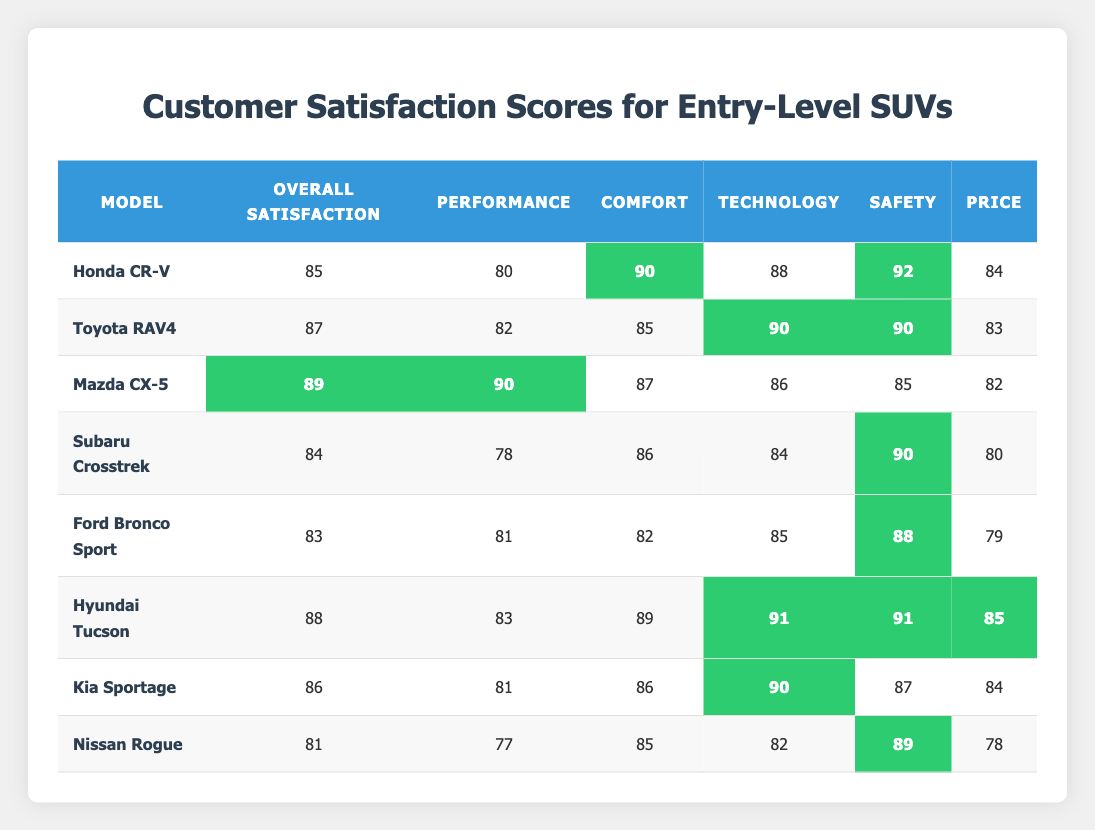What is the overall satisfaction score for the Mazda CX-5? The overall satisfaction score for the Mazda CX-5 is listed directly in the table and is indicated as 89.
Answer: 89 Which SUV has the highest comfort rating? According to the table, the Honda CR-V has the highest comfort rating of 90, and it is highlighted for this value.
Answer: Honda CR-V What is the average performance rating of these entry-level SUVs? To find the average performance rating, sum all the performance ratings: (80 + 82 + 90 + 78 + 81 + 83 + 81 + 77) = 552. Then divide by the number of SUVs (8) to get 552/8 = 69.
Answer: 69 True or False: The Hyundai Tucson has a higher overall satisfaction score than the Toyota RAV4. Comparing the overall satisfaction scores, the Hyundai Tucson has a score of 88, while the Toyota RAV4 has a score of 87, which confirms that the Hyundai Tucson does have a higher score.
Answer: True Which SUV has the lowest price rating? The Nissan Rogue has the lowest price rating listed in the table at 78, which is identifiable by scanning through the price ratings.
Answer: Nissan Rogue What is the difference in overall satisfaction scores between the Mazda CX-5 and the Ford Bronco Sport? The overall satisfaction score for the Mazda CX-5 is 89, while the Ford Bronco Sport's score is 83. The difference is calculated by subtracting the lower score from the higher: 89 - 83 = 6.
Answer: 6 Which model has the highest safety rating? The Honda CR-V and Hyundai Tucson both have the highest safety rating of 92 and 91 respectively, but the maximum listed is 92 from Honda CR-V.
Answer: Honda CR-V Which SUV scores lower in Technology than it does in Comfort? The Ford Bronco Sport has a technology rating of 85 and a comfort rating of 82, meaning it scores lower in technology.
Answer: Ford Bronco Sport What percentage of SUVs have comfort ratings greater than 85? Four out of the eight SUVs have comfort ratings greater than 85 (Honda CR-V, Mazda CX-5, Hyundai Tucson, and Kia Sportage). To find the percentage, calculate (4/8) * 100 = 50%.
Answer: 50% Which two models have the same lowest performance rating? Both the Nissan Rogue and the Subaru Crosstrek have the lowest performance rating of 77 and 78 respectively, making them the lowest performers.
Answer: Nissan Rogue and Subaru Crosstrek 